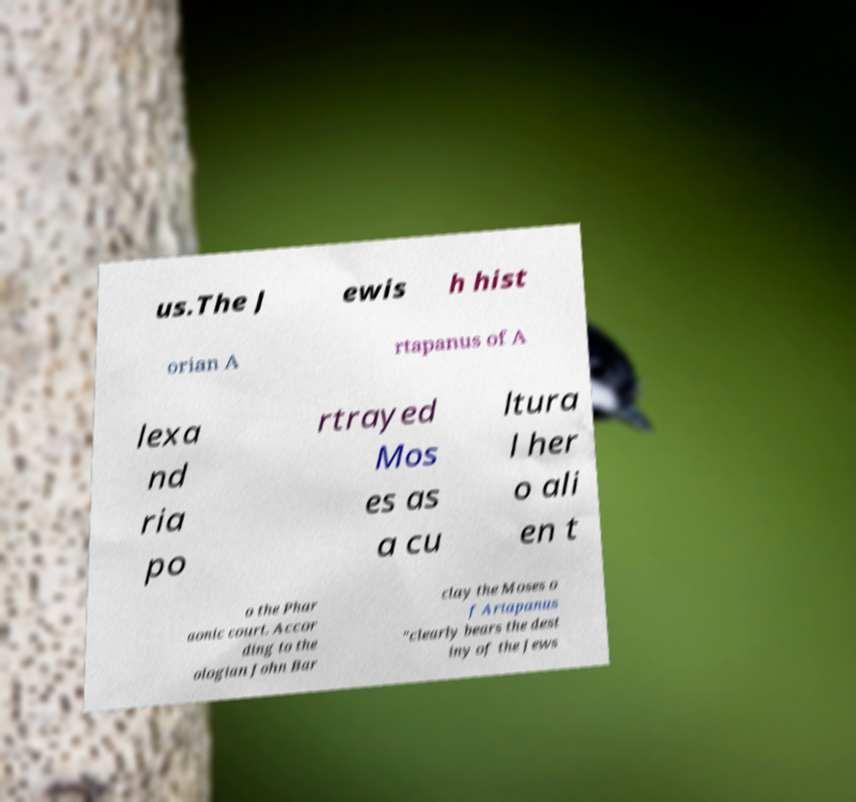Could you extract and type out the text from this image? us.The J ewis h hist orian A rtapanus of A lexa nd ria po rtrayed Mos es as a cu ltura l her o ali en t o the Phar aonic court. Accor ding to the ologian John Bar clay the Moses o f Artapanus "clearly bears the dest iny of the Jews 